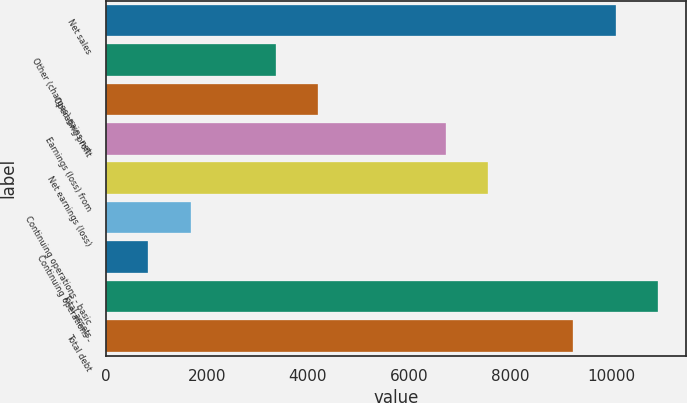Convert chart. <chart><loc_0><loc_0><loc_500><loc_500><bar_chart><fcel>Net sales<fcel>Other (charges) gains net<fcel>Operating profit<fcel>Earnings (loss) from<fcel>Net earnings (loss)<fcel>Continuing operations - basic<fcel>Continuing operations -<fcel>Total assets<fcel>Total debt<nl><fcel>10094.3<fcel>3364.88<fcel>4206.06<fcel>6729.6<fcel>7570.78<fcel>1682.52<fcel>841.34<fcel>10935.5<fcel>9253.14<nl></chart> 